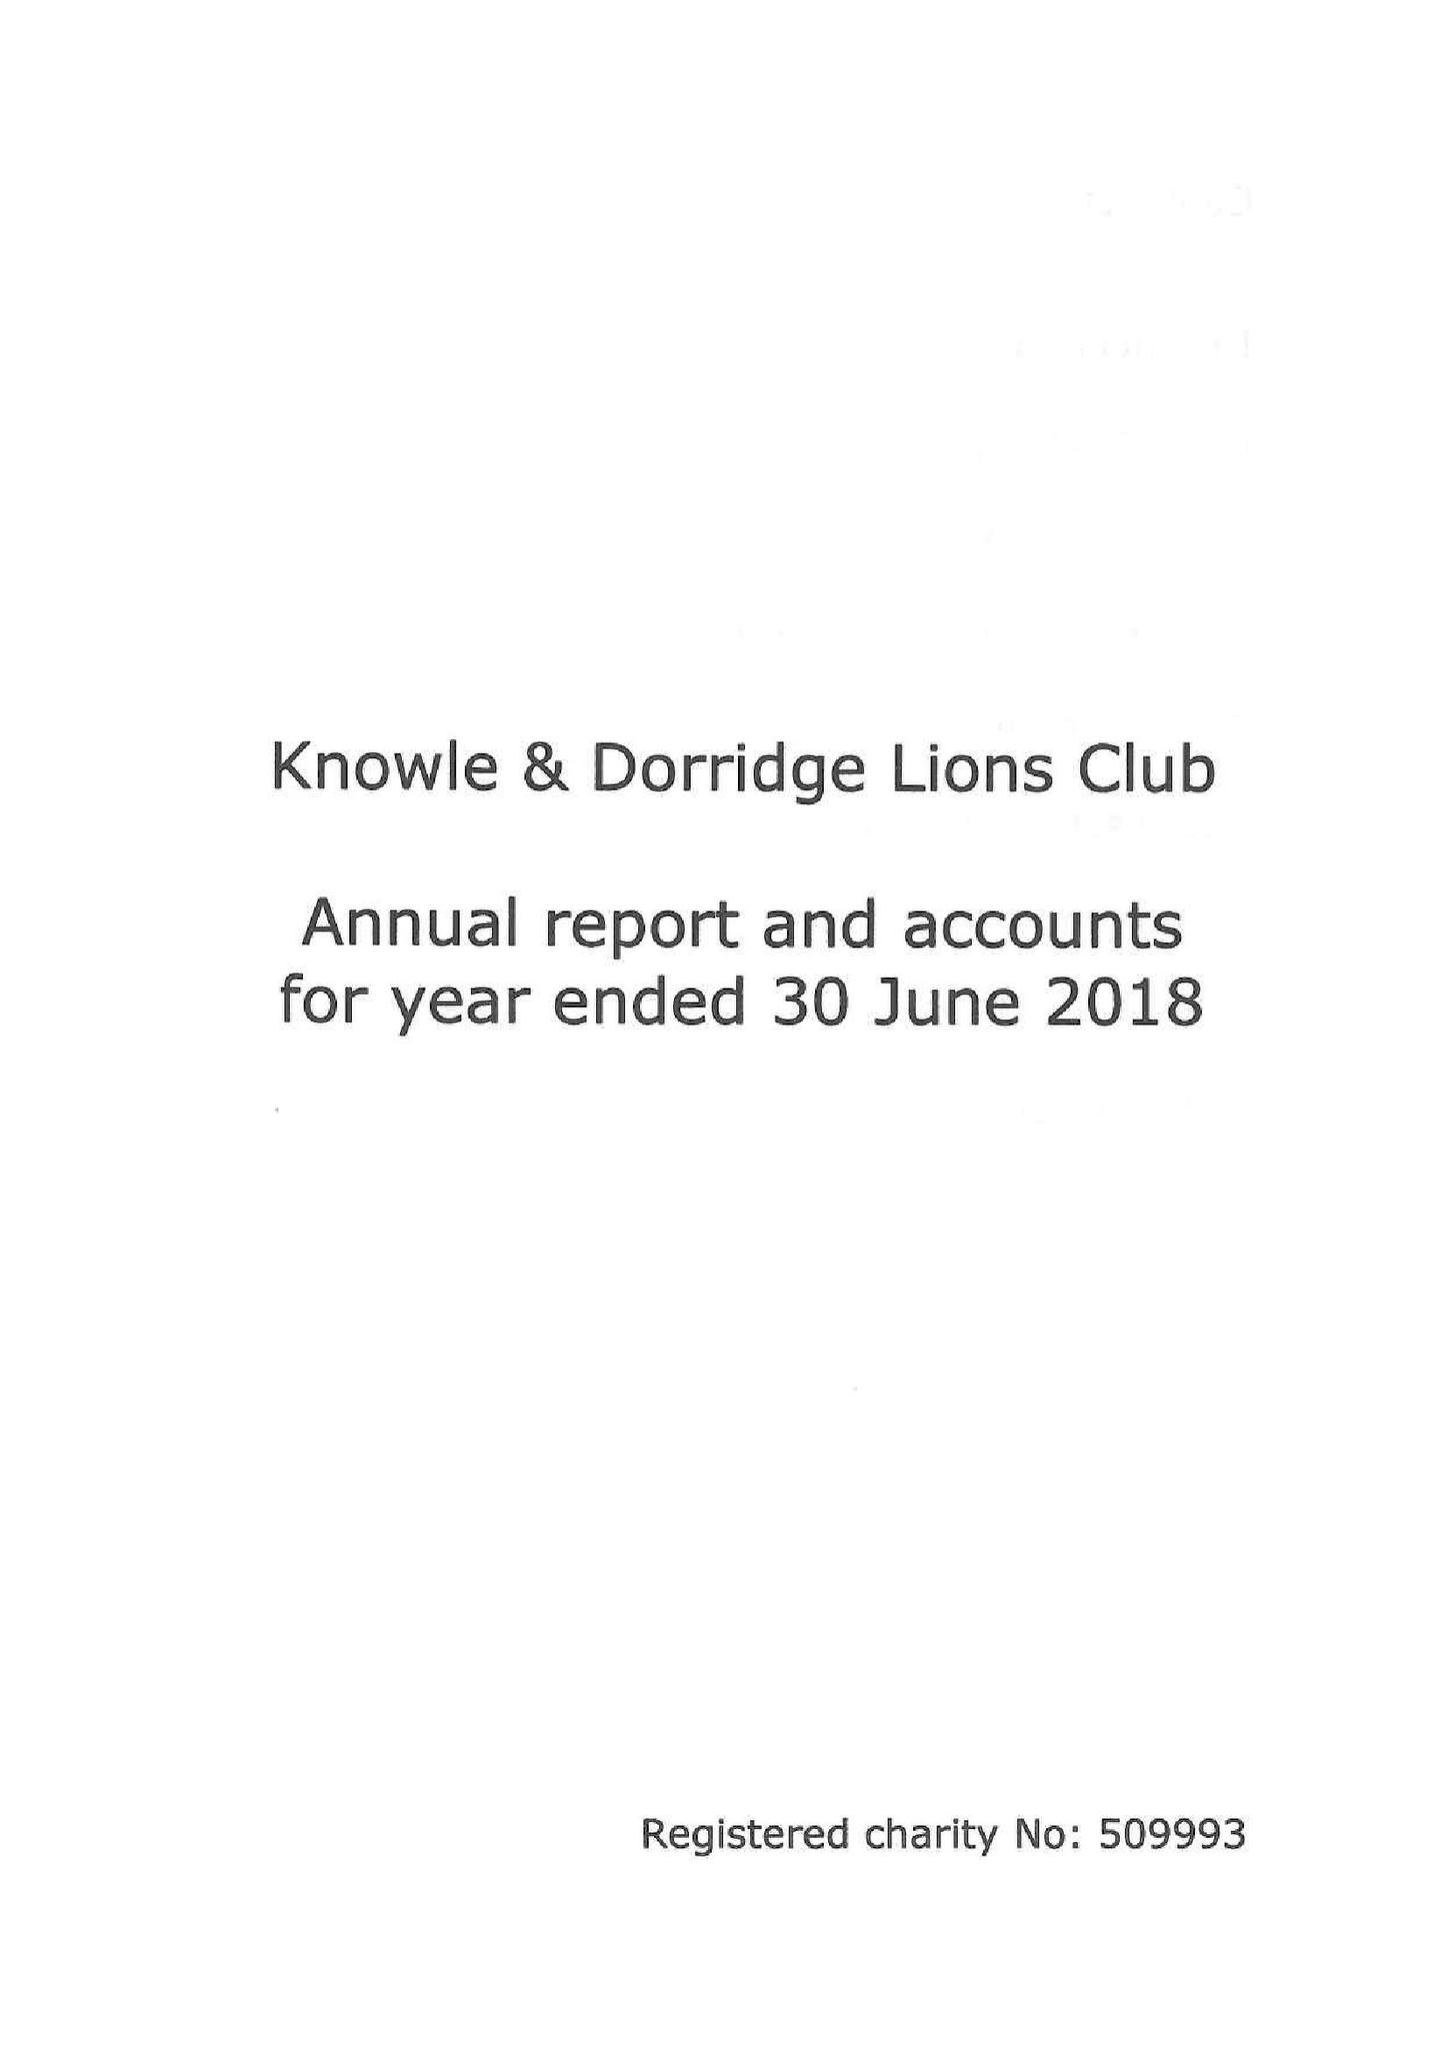What is the value for the spending_annually_in_british_pounds?
Answer the question using a single word or phrase. 53022.00 